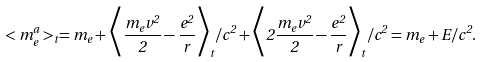Convert formula to latex. <formula><loc_0><loc_0><loc_500><loc_500>< m ^ { a } _ { e } > _ { t } = m _ { e } + \Big < \frac { m _ { e } v ^ { 2 } } { 2 } - \frac { e ^ { 2 } } { r } \Big > _ { t } / c ^ { 2 } + \Big < 2 \frac { m _ { e } v ^ { 2 } } { 2 } - \frac { e ^ { 2 } } { r } \Big > _ { t } / c ^ { 2 } = m _ { e } + E / c ^ { 2 } .</formula> 